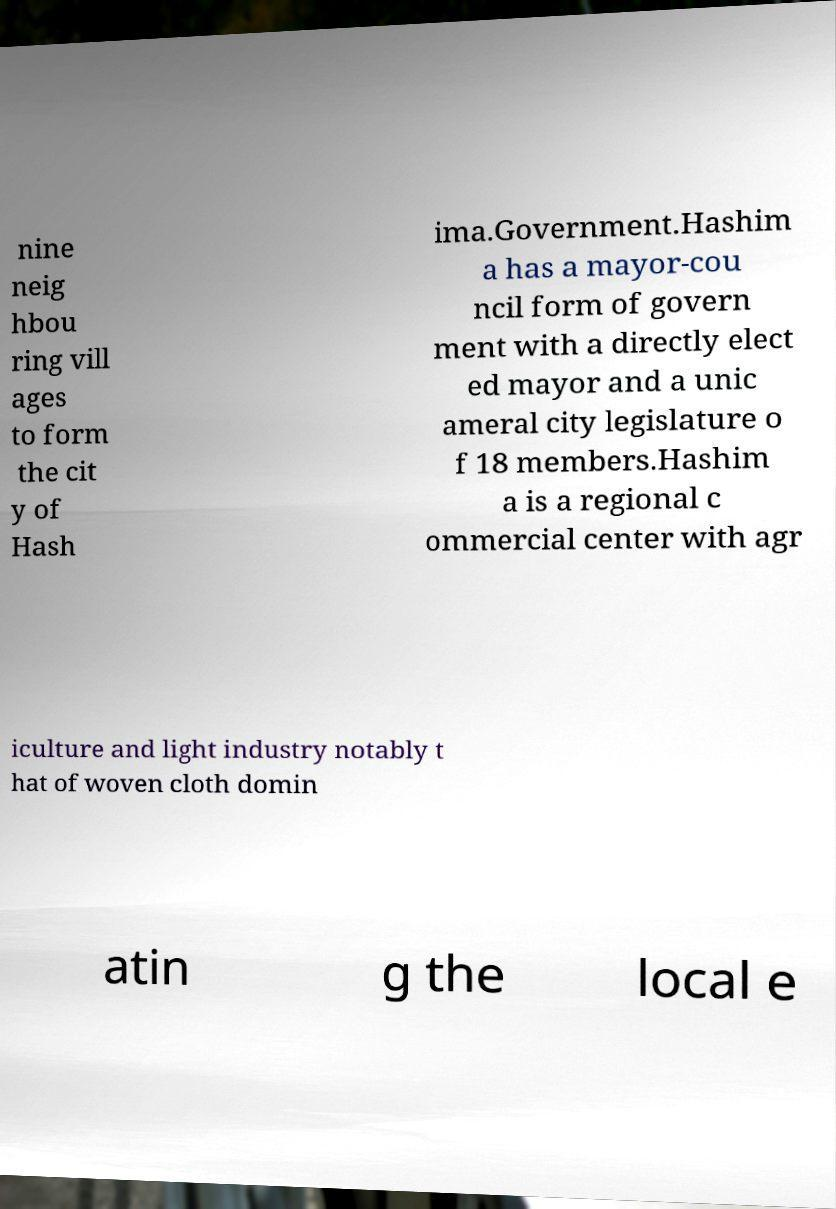Please identify and transcribe the text found in this image. nine neig hbou ring vill ages to form the cit y of Hash ima.Government.Hashim a has a mayor-cou ncil form of govern ment with a directly elect ed mayor and a unic ameral city legislature o f 18 members.Hashim a is a regional c ommercial center with agr iculture and light industry notably t hat of woven cloth domin atin g the local e 